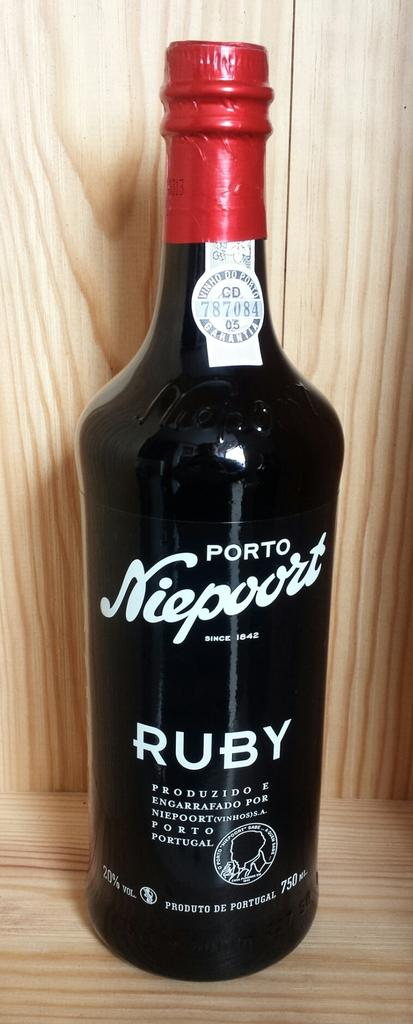<image>
Give a short and clear explanation of the subsequent image. A large bottle of Portuguese Ruby port sits on a wooden shelf. 